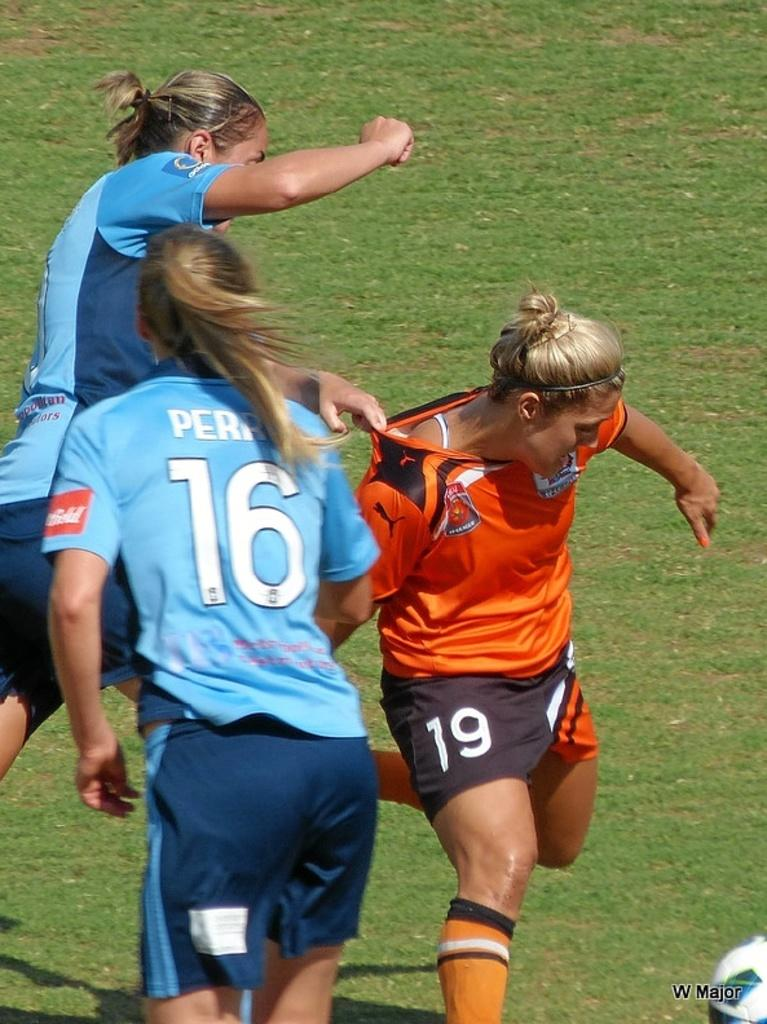Provide a one-sentence caption for the provided image. Female soccer players wearing numbers such as 16 and 19 jostling for the soccer ball. 